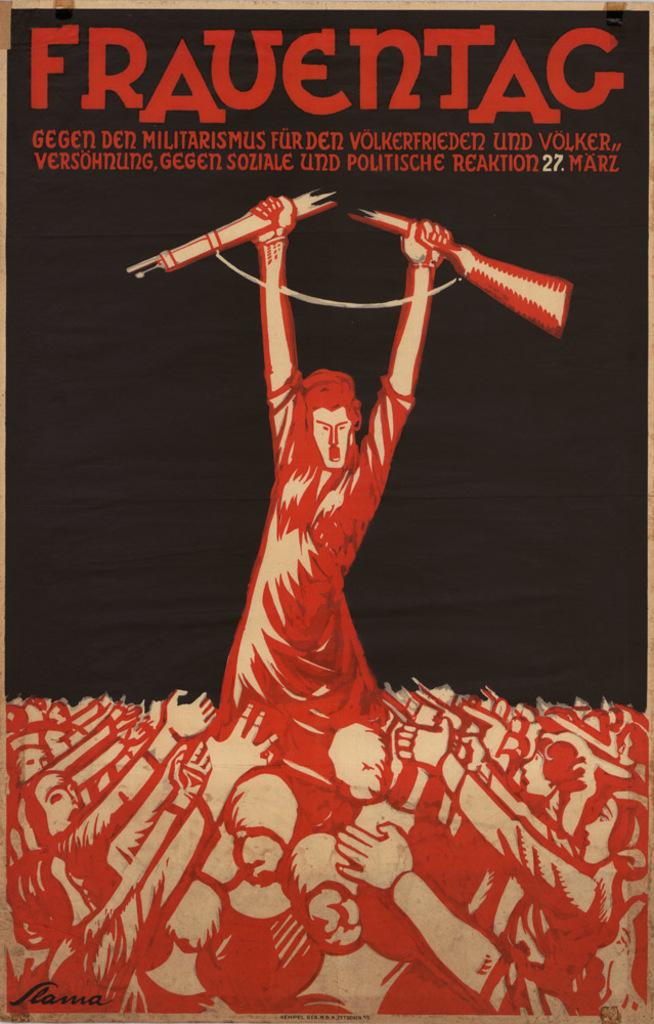What is the title of this movie?
Your response must be concise. Frauentag. What number on the page is in white letters?
Offer a very short reply. 27. 